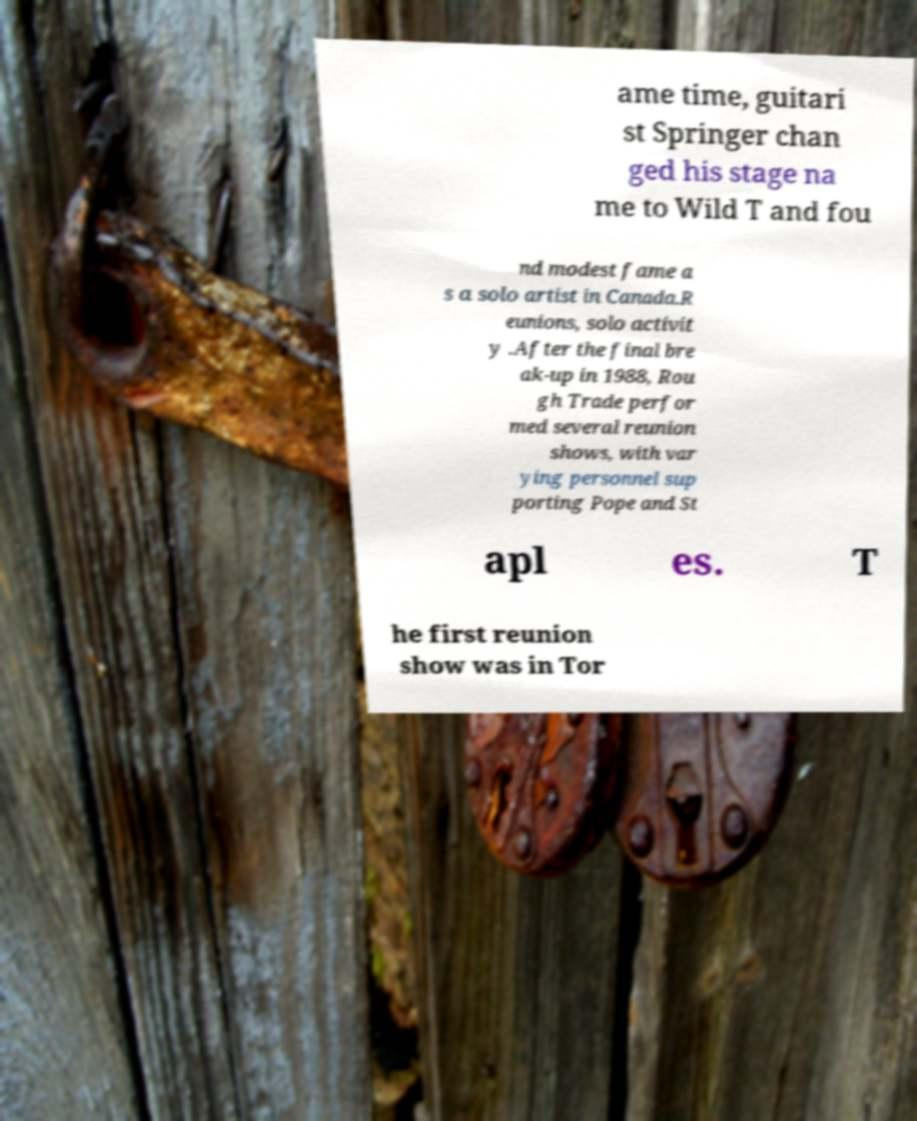Please read and relay the text visible in this image. What does it say? ame time, guitari st Springer chan ged his stage na me to Wild T and fou nd modest fame a s a solo artist in Canada.R eunions, solo activit y .After the final bre ak-up in 1988, Rou gh Trade perfor med several reunion shows, with var ying personnel sup porting Pope and St apl es. T he first reunion show was in Tor 